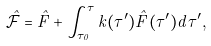<formula> <loc_0><loc_0><loc_500><loc_500>\hat { \mathcal { F } } = \hat { F } + \int ^ { \tau } _ { \tau _ { 0 } } k ( \tau ^ { \prime } ) \hat { F } ( \tau ^ { \prime } ) d \tau ^ { \prime } ,</formula> 